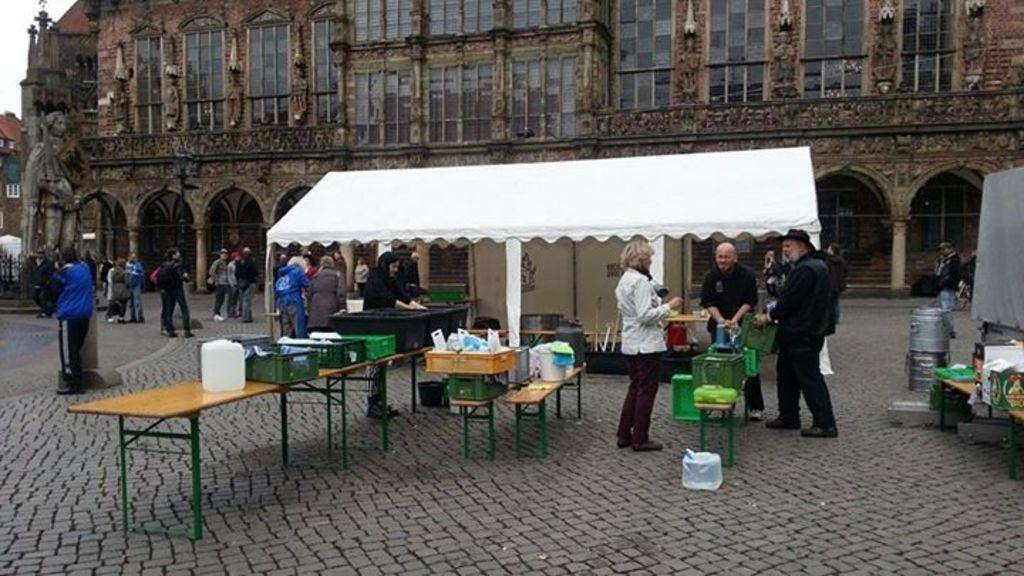What are the people in the image doing? The people in the image are standing on a road. Are the people interacting with each other or objects in the image? Yes, some people are giving objects in the image. What can be seen in the background of the image? There is a building with beautiful glass windows in the background of the image. What type of lawyer is depicted in the image? There is no lawyer present in the image. What is the kettle used for in the image? There is no kettle present in the image. 